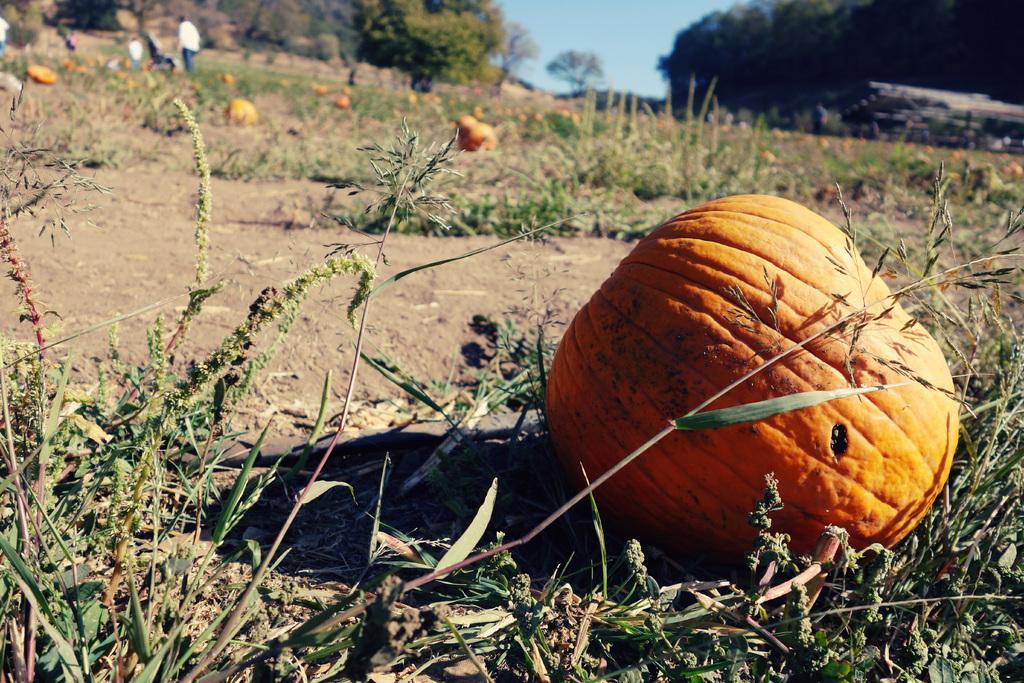In one or two sentences, can you explain what this image depicts? In this image we can see a group of pumpkins on the ground. In the foreground we can see plants. In the background, we can see a person standing on the ground, groups of trees and sky. 